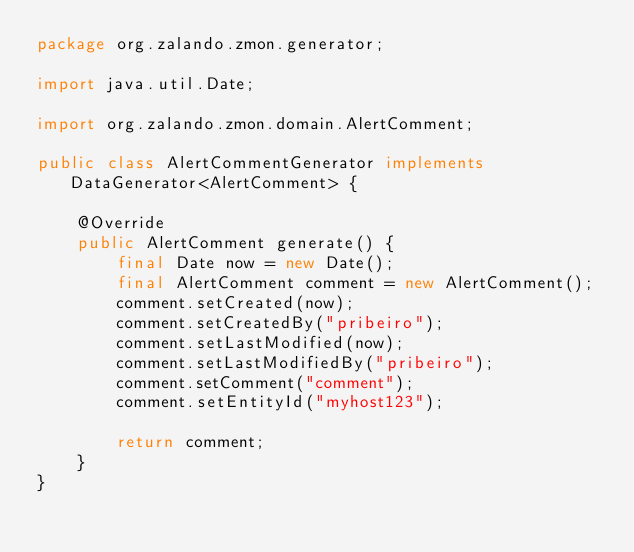<code> <loc_0><loc_0><loc_500><loc_500><_Java_>package org.zalando.zmon.generator;

import java.util.Date;

import org.zalando.zmon.domain.AlertComment;

public class AlertCommentGenerator implements DataGenerator<AlertComment> {

    @Override
    public AlertComment generate() {
        final Date now = new Date();
        final AlertComment comment = new AlertComment();
        comment.setCreated(now);
        comment.setCreatedBy("pribeiro");
        comment.setLastModified(now);
        comment.setLastModifiedBy("pribeiro");
        comment.setComment("comment");
        comment.setEntityId("myhost123");

        return comment;
    }
}
</code> 